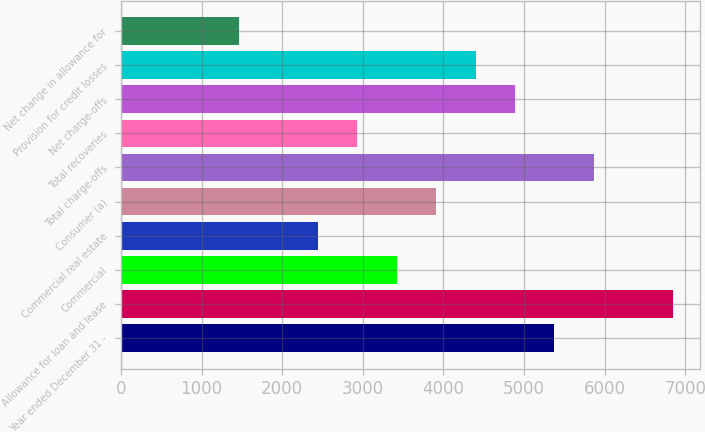Convert chart to OTSL. <chart><loc_0><loc_0><loc_500><loc_500><bar_chart><fcel>Year ended December 31 -<fcel>Allowance for loan and lease<fcel>Commercial<fcel>Commercial real estate<fcel>Consumer (a)<fcel>Total charge-offs<fcel>Total recoveries<fcel>Net charge-offs<fcel>Provision for credit losses<fcel>Net change in allowance for<nl><fcel>5375.58<fcel>6841.44<fcel>3421.1<fcel>2443.86<fcel>3909.72<fcel>5864.2<fcel>2932.48<fcel>4886.96<fcel>4398.34<fcel>1466.62<nl></chart> 